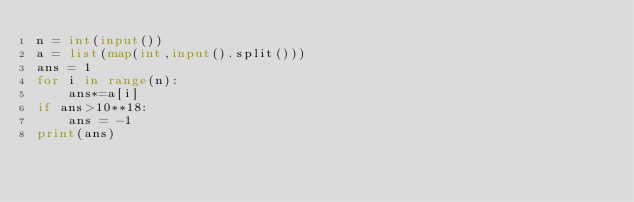Convert code to text. <code><loc_0><loc_0><loc_500><loc_500><_Python_>n = int(input())
a = list(map(int,input().split()))
ans = 1
for i in range(n):
    ans*=a[i]
if ans>10**18:
    ans = -1
print(ans)</code> 